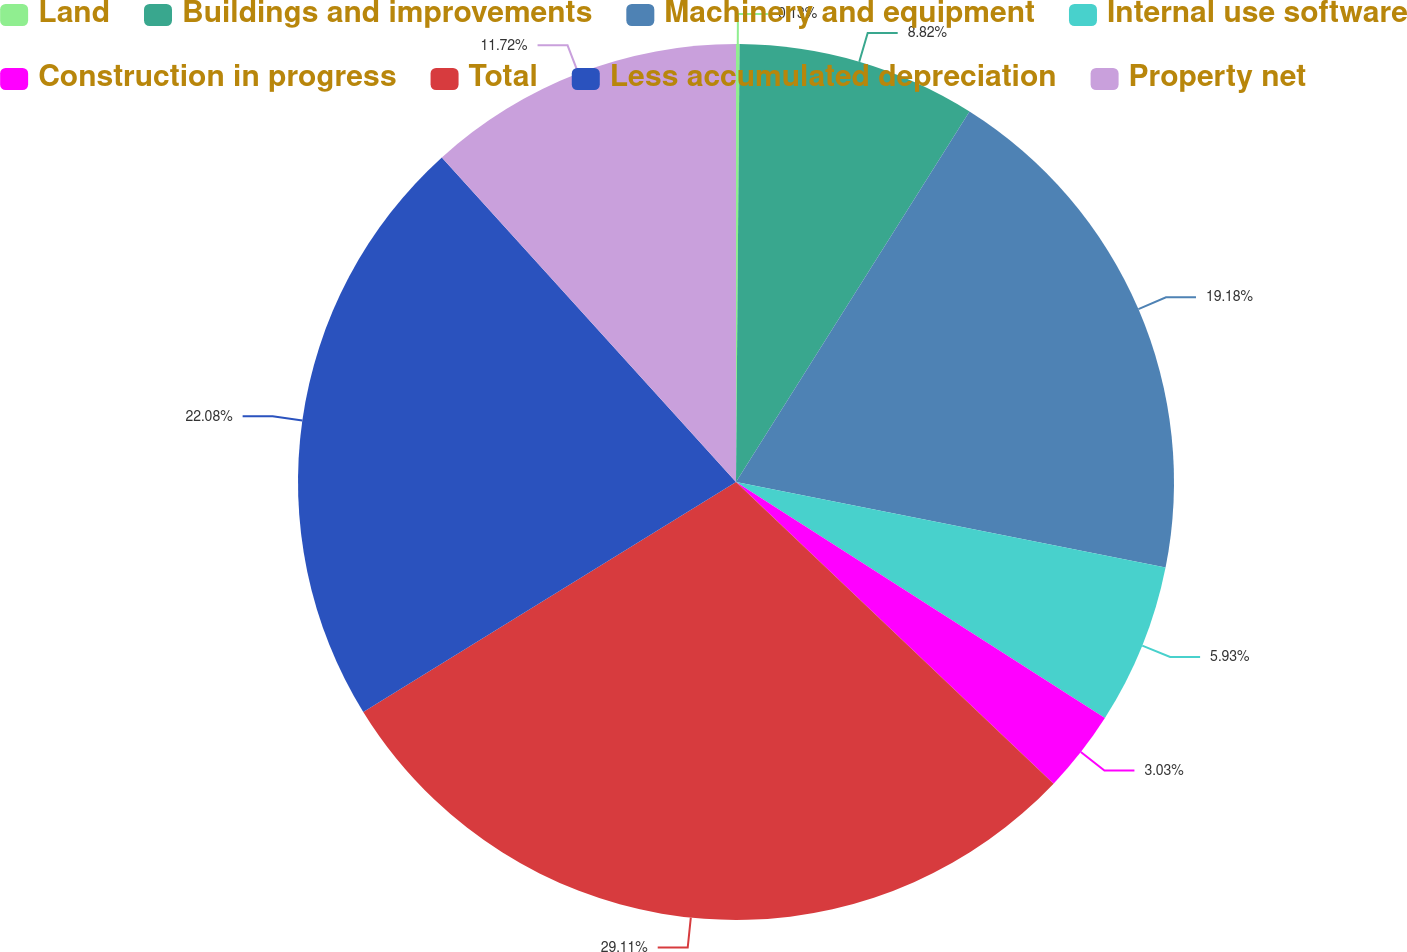Convert chart. <chart><loc_0><loc_0><loc_500><loc_500><pie_chart><fcel>Land<fcel>Buildings and improvements<fcel>Machinery and equipment<fcel>Internal use software<fcel>Construction in progress<fcel>Total<fcel>Less accumulated depreciation<fcel>Property net<nl><fcel>0.13%<fcel>8.82%<fcel>19.18%<fcel>5.93%<fcel>3.03%<fcel>29.11%<fcel>22.08%<fcel>11.72%<nl></chart> 